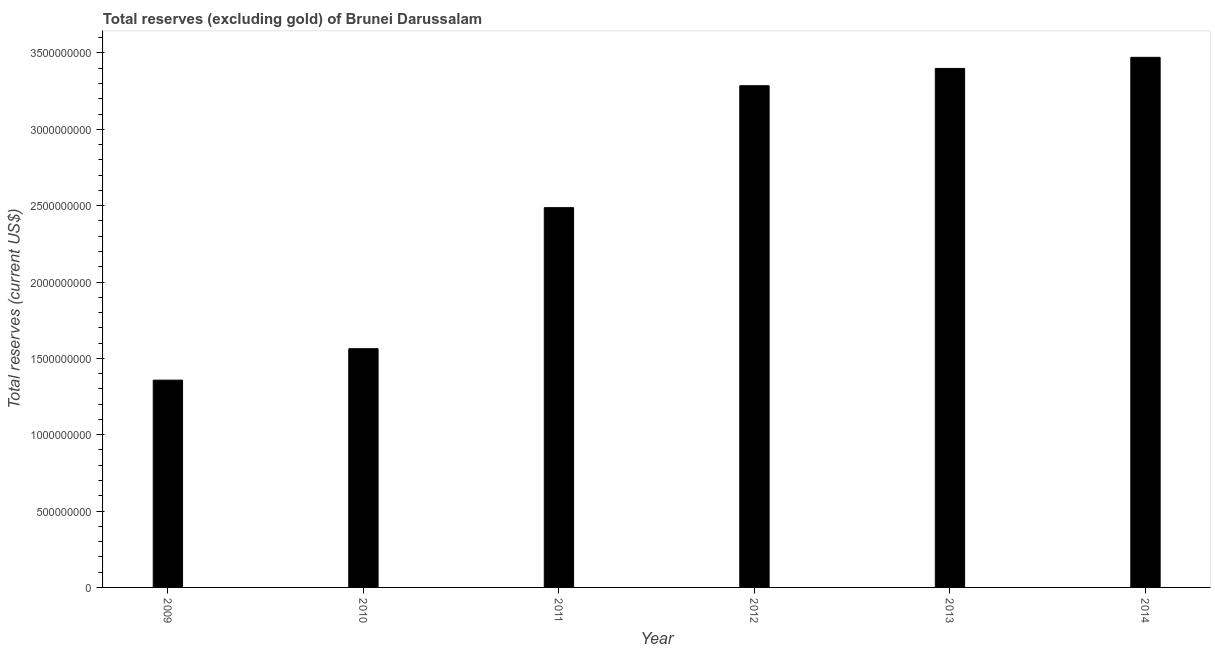Does the graph contain grids?
Make the answer very short. No. What is the title of the graph?
Your response must be concise. Total reserves (excluding gold) of Brunei Darussalam. What is the label or title of the X-axis?
Give a very brief answer. Year. What is the label or title of the Y-axis?
Provide a short and direct response. Total reserves (current US$). What is the total reserves (excluding gold) in 2011?
Offer a very short reply. 2.49e+09. Across all years, what is the maximum total reserves (excluding gold)?
Your answer should be very brief. 3.47e+09. Across all years, what is the minimum total reserves (excluding gold)?
Your answer should be compact. 1.36e+09. In which year was the total reserves (excluding gold) maximum?
Offer a terse response. 2014. In which year was the total reserves (excluding gold) minimum?
Ensure brevity in your answer.  2009. What is the sum of the total reserves (excluding gold)?
Make the answer very short. 1.56e+1. What is the difference between the total reserves (excluding gold) in 2010 and 2011?
Your response must be concise. -9.24e+08. What is the average total reserves (excluding gold) per year?
Provide a short and direct response. 2.59e+09. What is the median total reserves (excluding gold)?
Give a very brief answer. 2.89e+09. In how many years, is the total reserves (excluding gold) greater than 2000000000 US$?
Your response must be concise. 4. What is the ratio of the total reserves (excluding gold) in 2011 to that in 2012?
Offer a terse response. 0.76. Is the difference between the total reserves (excluding gold) in 2010 and 2013 greater than the difference between any two years?
Your answer should be compact. No. What is the difference between the highest and the second highest total reserves (excluding gold)?
Offer a terse response. 7.27e+07. Is the sum of the total reserves (excluding gold) in 2009 and 2012 greater than the maximum total reserves (excluding gold) across all years?
Keep it short and to the point. Yes. What is the difference between the highest and the lowest total reserves (excluding gold)?
Offer a very short reply. 2.11e+09. Are the values on the major ticks of Y-axis written in scientific E-notation?
Provide a short and direct response. No. What is the Total reserves (current US$) in 2009?
Give a very brief answer. 1.36e+09. What is the Total reserves (current US$) in 2010?
Offer a very short reply. 1.56e+09. What is the Total reserves (current US$) of 2011?
Provide a short and direct response. 2.49e+09. What is the Total reserves (current US$) in 2012?
Give a very brief answer. 3.29e+09. What is the Total reserves (current US$) in 2013?
Offer a terse response. 3.40e+09. What is the Total reserves (current US$) in 2014?
Make the answer very short. 3.47e+09. What is the difference between the Total reserves (current US$) in 2009 and 2010?
Your answer should be very brief. -2.06e+08. What is the difference between the Total reserves (current US$) in 2009 and 2011?
Keep it short and to the point. -1.13e+09. What is the difference between the Total reserves (current US$) in 2009 and 2012?
Give a very brief answer. -1.93e+09. What is the difference between the Total reserves (current US$) in 2009 and 2013?
Make the answer very short. -2.04e+09. What is the difference between the Total reserves (current US$) in 2009 and 2014?
Keep it short and to the point. -2.11e+09. What is the difference between the Total reserves (current US$) in 2010 and 2011?
Provide a succinct answer. -9.24e+08. What is the difference between the Total reserves (current US$) in 2010 and 2012?
Give a very brief answer. -1.72e+09. What is the difference between the Total reserves (current US$) in 2010 and 2013?
Your answer should be compact. -1.84e+09. What is the difference between the Total reserves (current US$) in 2010 and 2014?
Your answer should be very brief. -1.91e+09. What is the difference between the Total reserves (current US$) in 2011 and 2012?
Keep it short and to the point. -7.99e+08. What is the difference between the Total reserves (current US$) in 2011 and 2013?
Your answer should be very brief. -9.12e+08. What is the difference between the Total reserves (current US$) in 2011 and 2014?
Offer a very short reply. -9.84e+08. What is the difference between the Total reserves (current US$) in 2012 and 2013?
Provide a succinct answer. -1.13e+08. What is the difference between the Total reserves (current US$) in 2012 and 2014?
Ensure brevity in your answer.  -1.86e+08. What is the difference between the Total reserves (current US$) in 2013 and 2014?
Your response must be concise. -7.27e+07. What is the ratio of the Total reserves (current US$) in 2009 to that in 2010?
Give a very brief answer. 0.87. What is the ratio of the Total reserves (current US$) in 2009 to that in 2011?
Make the answer very short. 0.55. What is the ratio of the Total reserves (current US$) in 2009 to that in 2012?
Your answer should be very brief. 0.41. What is the ratio of the Total reserves (current US$) in 2009 to that in 2013?
Give a very brief answer. 0.4. What is the ratio of the Total reserves (current US$) in 2009 to that in 2014?
Your response must be concise. 0.39. What is the ratio of the Total reserves (current US$) in 2010 to that in 2011?
Offer a terse response. 0.63. What is the ratio of the Total reserves (current US$) in 2010 to that in 2012?
Ensure brevity in your answer.  0.48. What is the ratio of the Total reserves (current US$) in 2010 to that in 2013?
Provide a short and direct response. 0.46. What is the ratio of the Total reserves (current US$) in 2010 to that in 2014?
Your response must be concise. 0.45. What is the ratio of the Total reserves (current US$) in 2011 to that in 2012?
Offer a terse response. 0.76. What is the ratio of the Total reserves (current US$) in 2011 to that in 2013?
Offer a terse response. 0.73. What is the ratio of the Total reserves (current US$) in 2011 to that in 2014?
Make the answer very short. 0.72. What is the ratio of the Total reserves (current US$) in 2012 to that in 2014?
Make the answer very short. 0.95. What is the ratio of the Total reserves (current US$) in 2013 to that in 2014?
Provide a short and direct response. 0.98. 